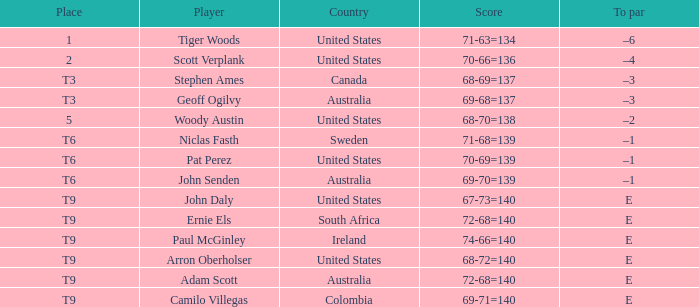In which country was adam scott born? Australia. 